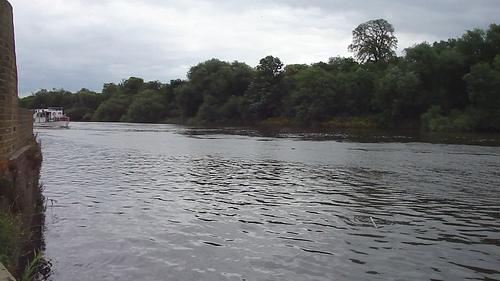Question: what is white?
Choices:
A. The driveway.
B. The shirt.
C. The wall.
D. Boat.
Answer with the letter. Answer: D Question: where was the picture taken?
Choices:
A. At my house.
B. Lake.
C. At the game.
D. In the museum.
Answer with the letter. Answer: B Question: what is green?
Choices:
A. Grass.
B. My car.
C. The shutters.
D. Trees.
Answer with the letter. Answer: D Question: when will the waves be choppy?
Choices:
A. When it is hot.
B. When the water is churning.
C. When the storm comes.
D. When it is windy.
Answer with the letter. Answer: D Question: what is blue?
Choices:
A. The truck.
B. The roof.
C. The sign.
D. Sky.
Answer with the letter. Answer: D 